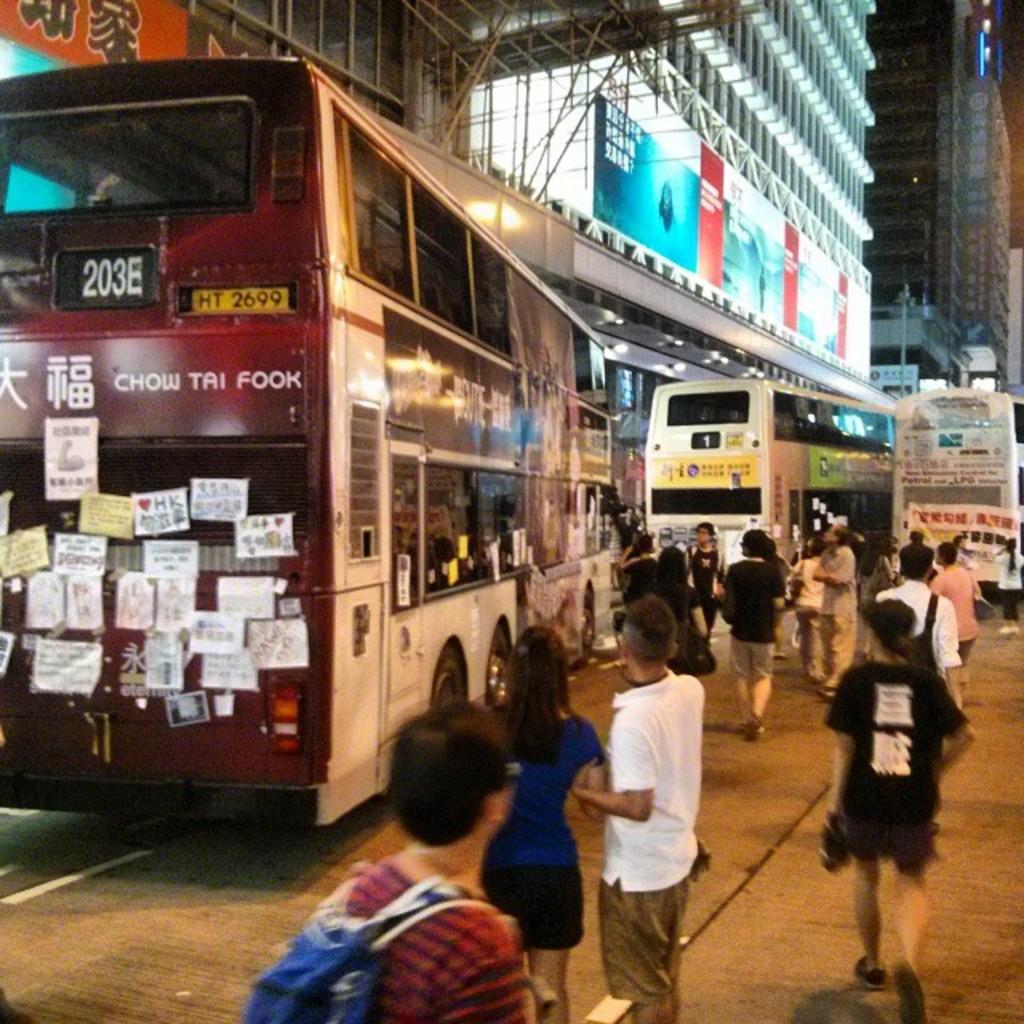Where is the bus going?
Keep it short and to the point. Unanswerable. What is the route number?
Your response must be concise. 203b. 